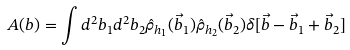<formula> <loc_0><loc_0><loc_500><loc_500>A ( b ) = \int d ^ { 2 } b _ { 1 } d ^ { 2 } b _ { 2 } \hat { \rho } _ { h _ { 1 } } ( \vec { b } _ { 1 } ) \hat { \rho } _ { h _ { 2 } } ( \vec { b } _ { 2 } ) \delta [ \vec { b } - \vec { b } _ { 1 } + \vec { b } _ { 2 } ]</formula> 